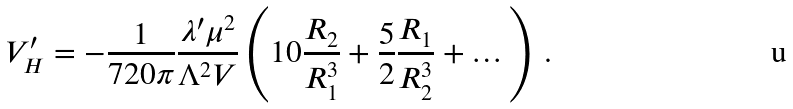Convert formula to latex. <formula><loc_0><loc_0><loc_500><loc_500>V ^ { \prime } _ { H } = - \frac { 1 } { 7 2 0 \pi } \frac { \lambda ^ { \prime } \mu ^ { 2 } } { \Lambda ^ { 2 } V } \left ( 1 0 \frac { R _ { 2 } } { R _ { 1 } ^ { 3 } } + \frac { 5 } { 2 } \frac { R _ { 1 } } { R _ { 2 } ^ { 3 } } + \dots \right ) \, .</formula> 